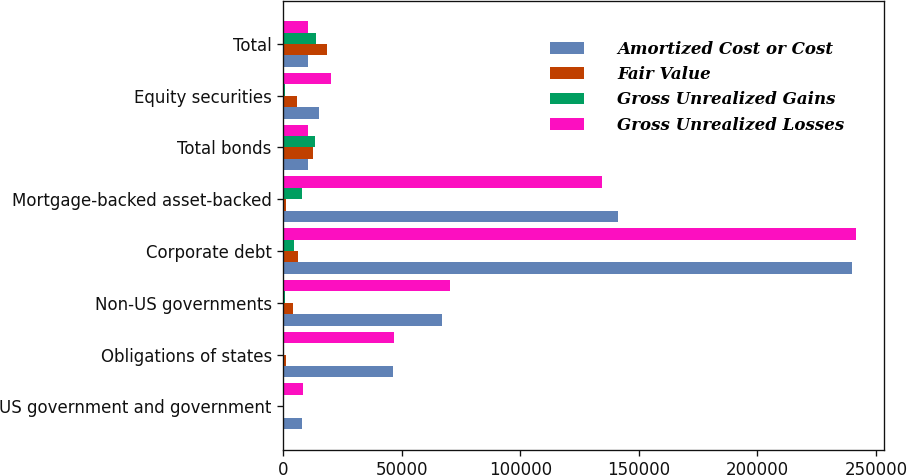Convert chart. <chart><loc_0><loc_0><loc_500><loc_500><stacked_bar_chart><ecel><fcel>US government and government<fcel>Obligations of states<fcel>Non-US governments<fcel>Corporate debt<fcel>Mortgage-backed asset-backed<fcel>Total bonds<fcel>Equity securities<fcel>Total<nl><fcel>Amortized Cost or Cost<fcel>7956<fcel>46087<fcel>67023<fcel>239822<fcel>140982<fcel>10434.5<fcel>15188<fcel>10434.5<nl><fcel>Fair Value<fcel>333<fcel>927<fcel>3920<fcel>6216<fcel>1221<fcel>12617<fcel>5545<fcel>18162<nl><fcel>Gross Unrealized Gains<fcel>37<fcel>160<fcel>743<fcel>4518<fcel>7703<fcel>13161<fcel>463<fcel>13624<nl><fcel>Gross Unrealized Losses<fcel>8252<fcel>46854<fcel>70200<fcel>241520<fcel>134500<fcel>10434.5<fcel>20270<fcel>10434.5<nl></chart> 